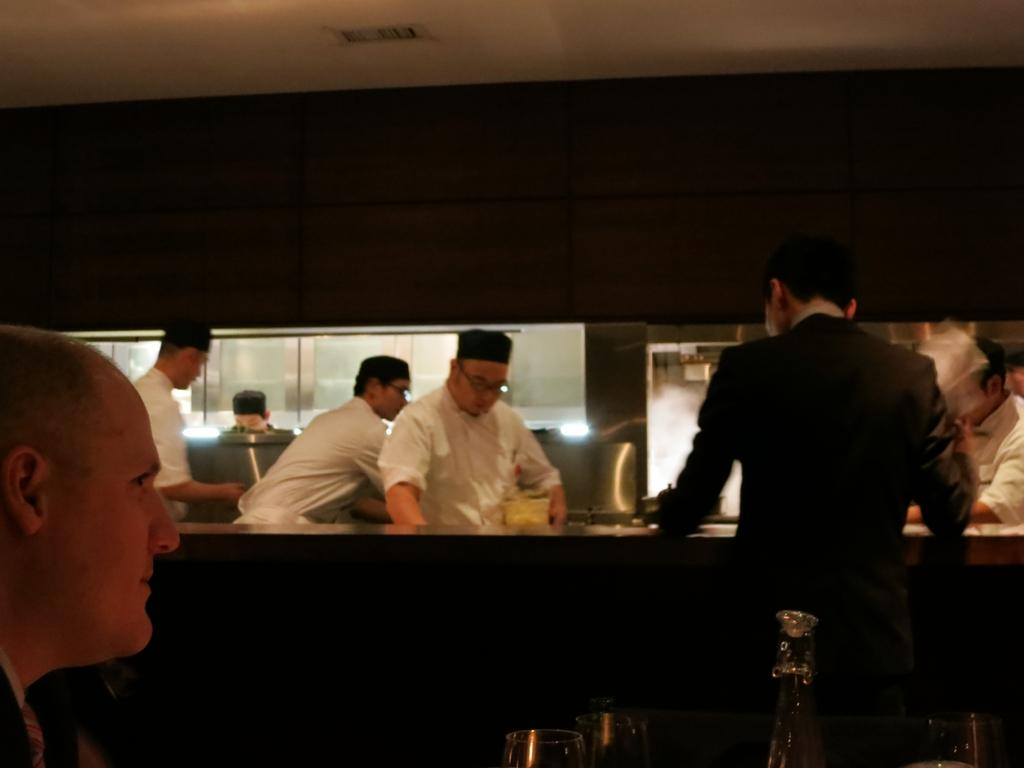How many people are in the image? There is a group of people in the image. What is the position of the man in the image? A man is seated in the image. Are there any people standing in the image? Yes, there are people standing in the image. What objects are in the middle of the image? There are glasses and a bottle in the middle of the image. What type of appliance can be seen on the slope in the image? There is no appliance or slope present in the image. 